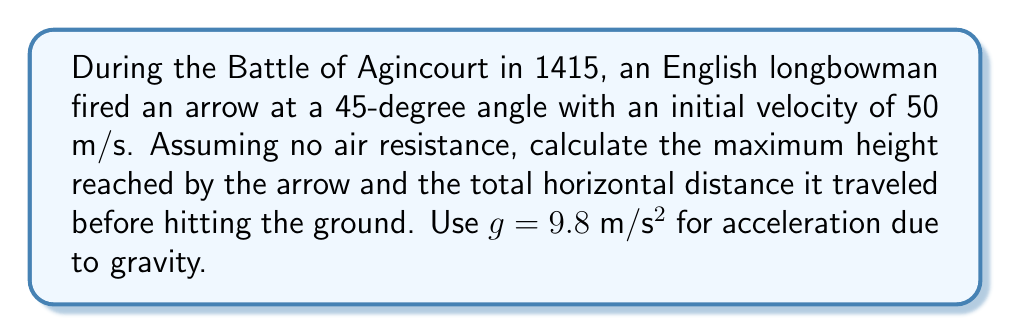Teach me how to tackle this problem. To solve this problem, we'll use the equations of projectile motion. Let's break it down step-by-step:

1. Given information:
   - Initial velocity, $v_0 = 50$ m/s
   - Angle of projection, $\theta = 45°$
   - Acceleration due to gravity, $g = 9.8$ m/s²

2. Calculate the initial vertical and horizontal components of velocity:
   $v_{0x} = v_0 \cos \theta = 50 \cos 45° = 50 \cdot \frac{\sqrt{2}}{2} \approx 35.36$ m/s
   $v_{0y} = v_0 \sin \theta = 50 \sin 45° = 50 \cdot \frac{\sqrt{2}}{2} \approx 35.36$ m/s

3. Calculate the maximum height:
   The maximum height occurs when the vertical velocity becomes zero.
   Using the equation: $v_y^2 = v_{0y}^2 - 2gh_{max}$
   $0 = v_{0y}^2 - 2gh_{max}$
   $h_{max} = \frac{v_{0y}^2}{2g} = \frac{(35.36)^2}{2(9.8)} \approx 63.78$ m

4. Calculate the time to reach maximum height:
   $t_{up} = \frac{v_{0y}}{g} = \frac{35.36}{9.8} \approx 3.61$ s

5. Calculate the total time of flight:
   The total time is twice the time to reach maximum height.
   $t_{total} = 2t_{up} = 2(3.61) \approx 7.22$ s

6. Calculate the horizontal distance traveled:
   $d = v_{0x} \cdot t_{total} = 35.36 \cdot 7.22 \approx 255.30$ m

Therefore, the maximum height reached by the arrow is approximately 63.78 meters, and the total horizontal distance traveled is approximately 255.30 meters.
Answer: Maximum height: 63.78 m, Horizontal distance: 255.30 m 